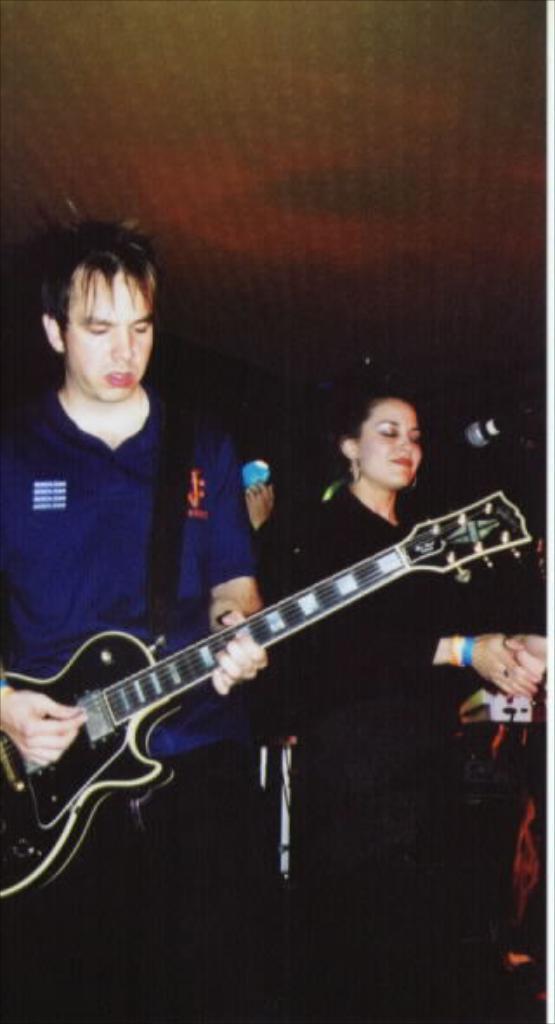Can you describe this image briefly? This 2 persons are standing. This man is holding a guitar. 